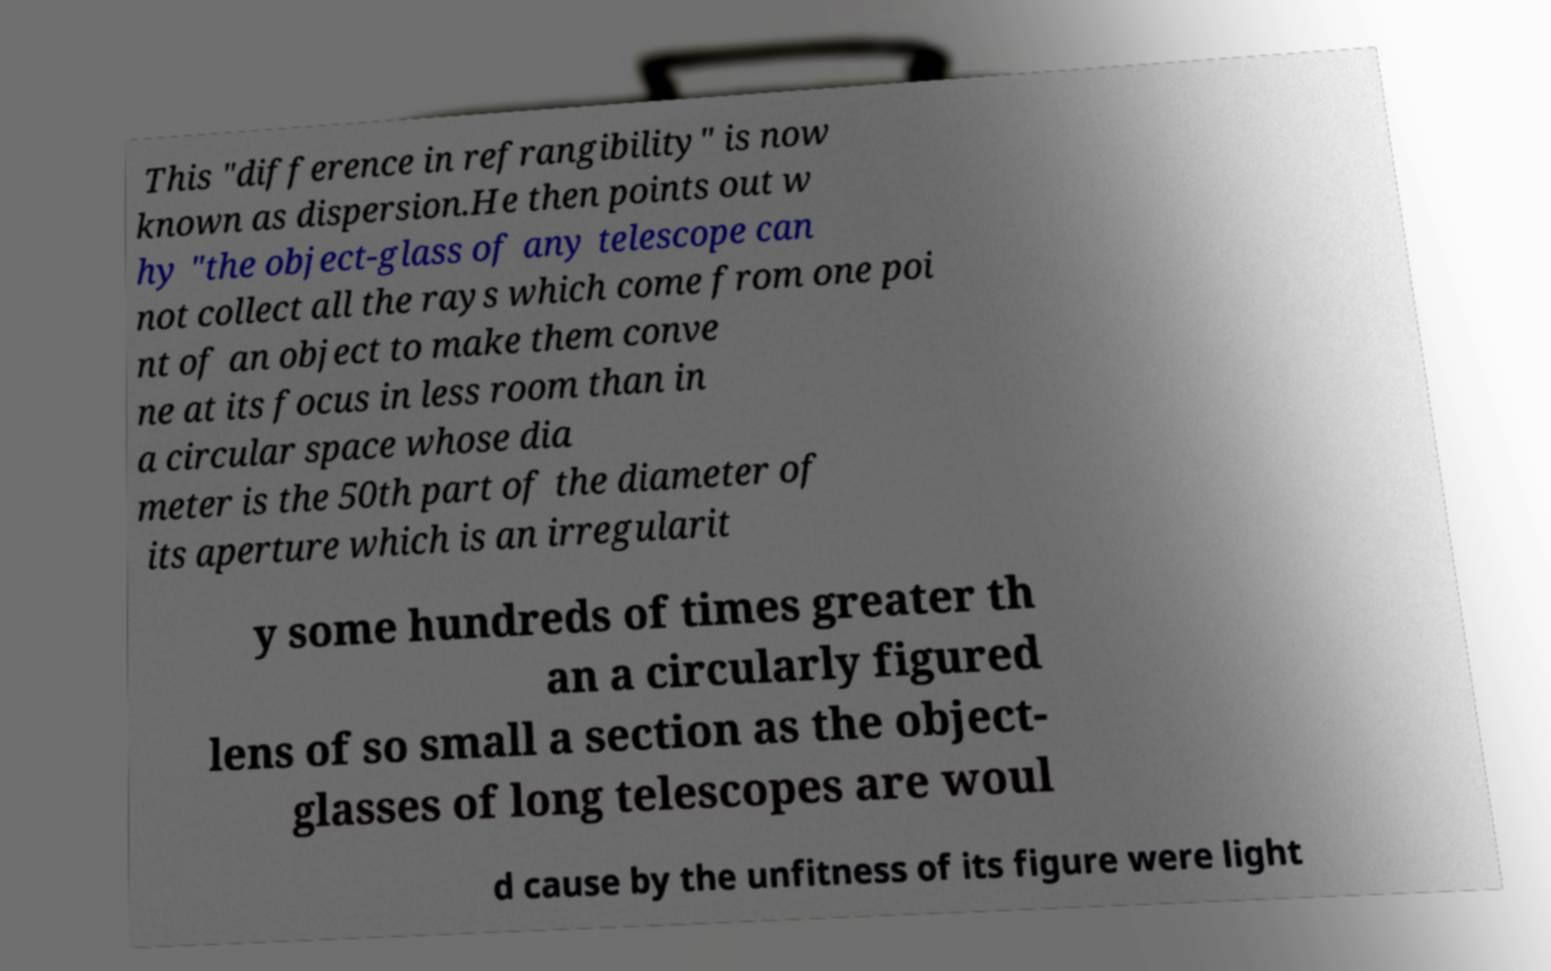For documentation purposes, I need the text within this image transcribed. Could you provide that? This "difference in refrangibility" is now known as dispersion.He then points out w hy "the object-glass of any telescope can not collect all the rays which come from one poi nt of an object to make them conve ne at its focus in less room than in a circular space whose dia meter is the 50th part of the diameter of its aperture which is an irregularit y some hundreds of times greater th an a circularly figured lens of so small a section as the object- glasses of long telescopes are woul d cause by the unfitness of its figure were light 